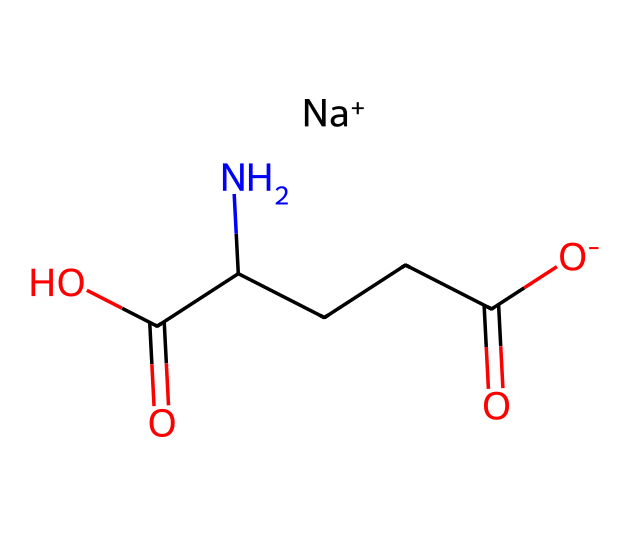What is the full name of this chemical? The SMILES representation indicates the molecular structure, which corresponds to monosodium glutamate, a common flavor enhancer used in food.
Answer: monosodium glutamate How many carbon atoms are present in this molecule? Count the 'C' letters in the chemical structure; there are five 'C' symbols indicating five carbon atoms.
Answer: 5 What type of ion is represented by "Na+" in the chemical? The "Na+" indicates a sodium ion, which denotes that this compound is a sodium salt of glutamic acid.
Answer: sodium ion What functional groups are present in this structure? Analyzing the structure shows both carboxylic acid groups (-COOH) and an amine group (-NH2), identifying these as the main functional groups in the compound.
Answer: carboxylic acid, amine How many carboxylic acid groups are in this molecule? By examining the structure, we find two '-COOH' (carboxylic acid) representations, confirming the presence of two carboxylic acid groups.
Answer: 2 What is the role of MSG in luxury cuisine? MSG acts as a flavor enhancer, elevating umami flavor and enhancing the overall taste experience in high-end culinary dishes.
Answer: flavor enhancer Is this compound naturally occurring? Monosodium glutamate can be found naturally in foods such as tomatoes and cheese, but is also produced synthetically for widespread use in cooking.
Answer: yes 